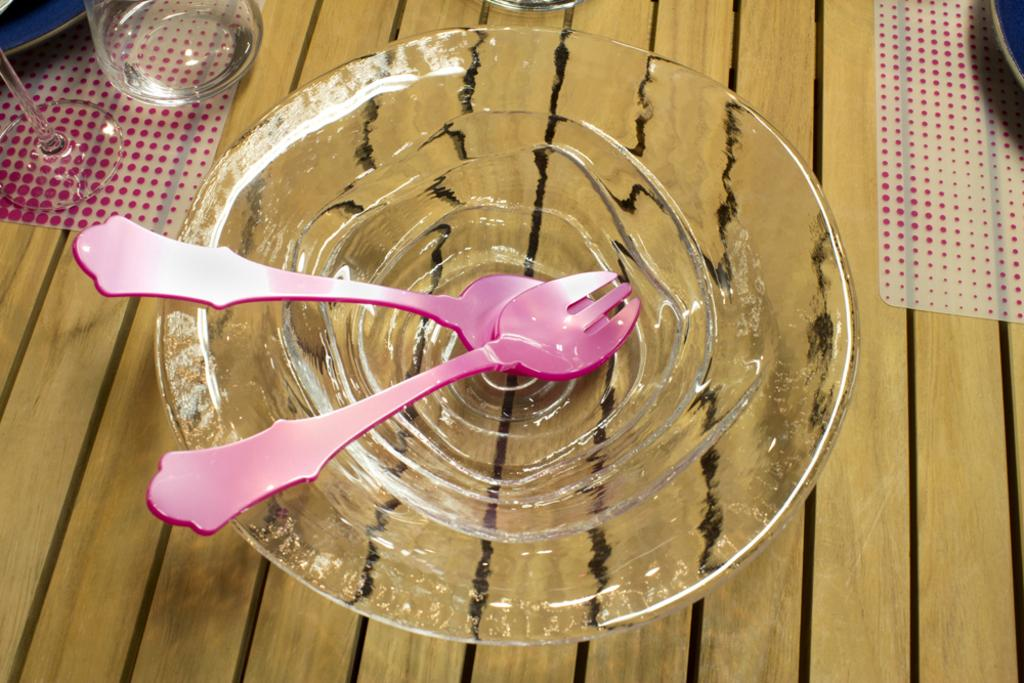What type of container is visible in the image? There is a glass bowl in the image. What utensils are inside the glass bowl? There is a fork and a spoon inside the glass bowl. Where is the glass bowl located? The glass bowl is on a table. What other items can be seen in the background of the image? There are glasses, plates, and table mats in the background of the image. How many pets are visible in the image? There are no pets visible in the image. What type of house is shown in the image? The image does not show a house; it only shows a table with a glass bowl and utensils, along with some items in the background. 